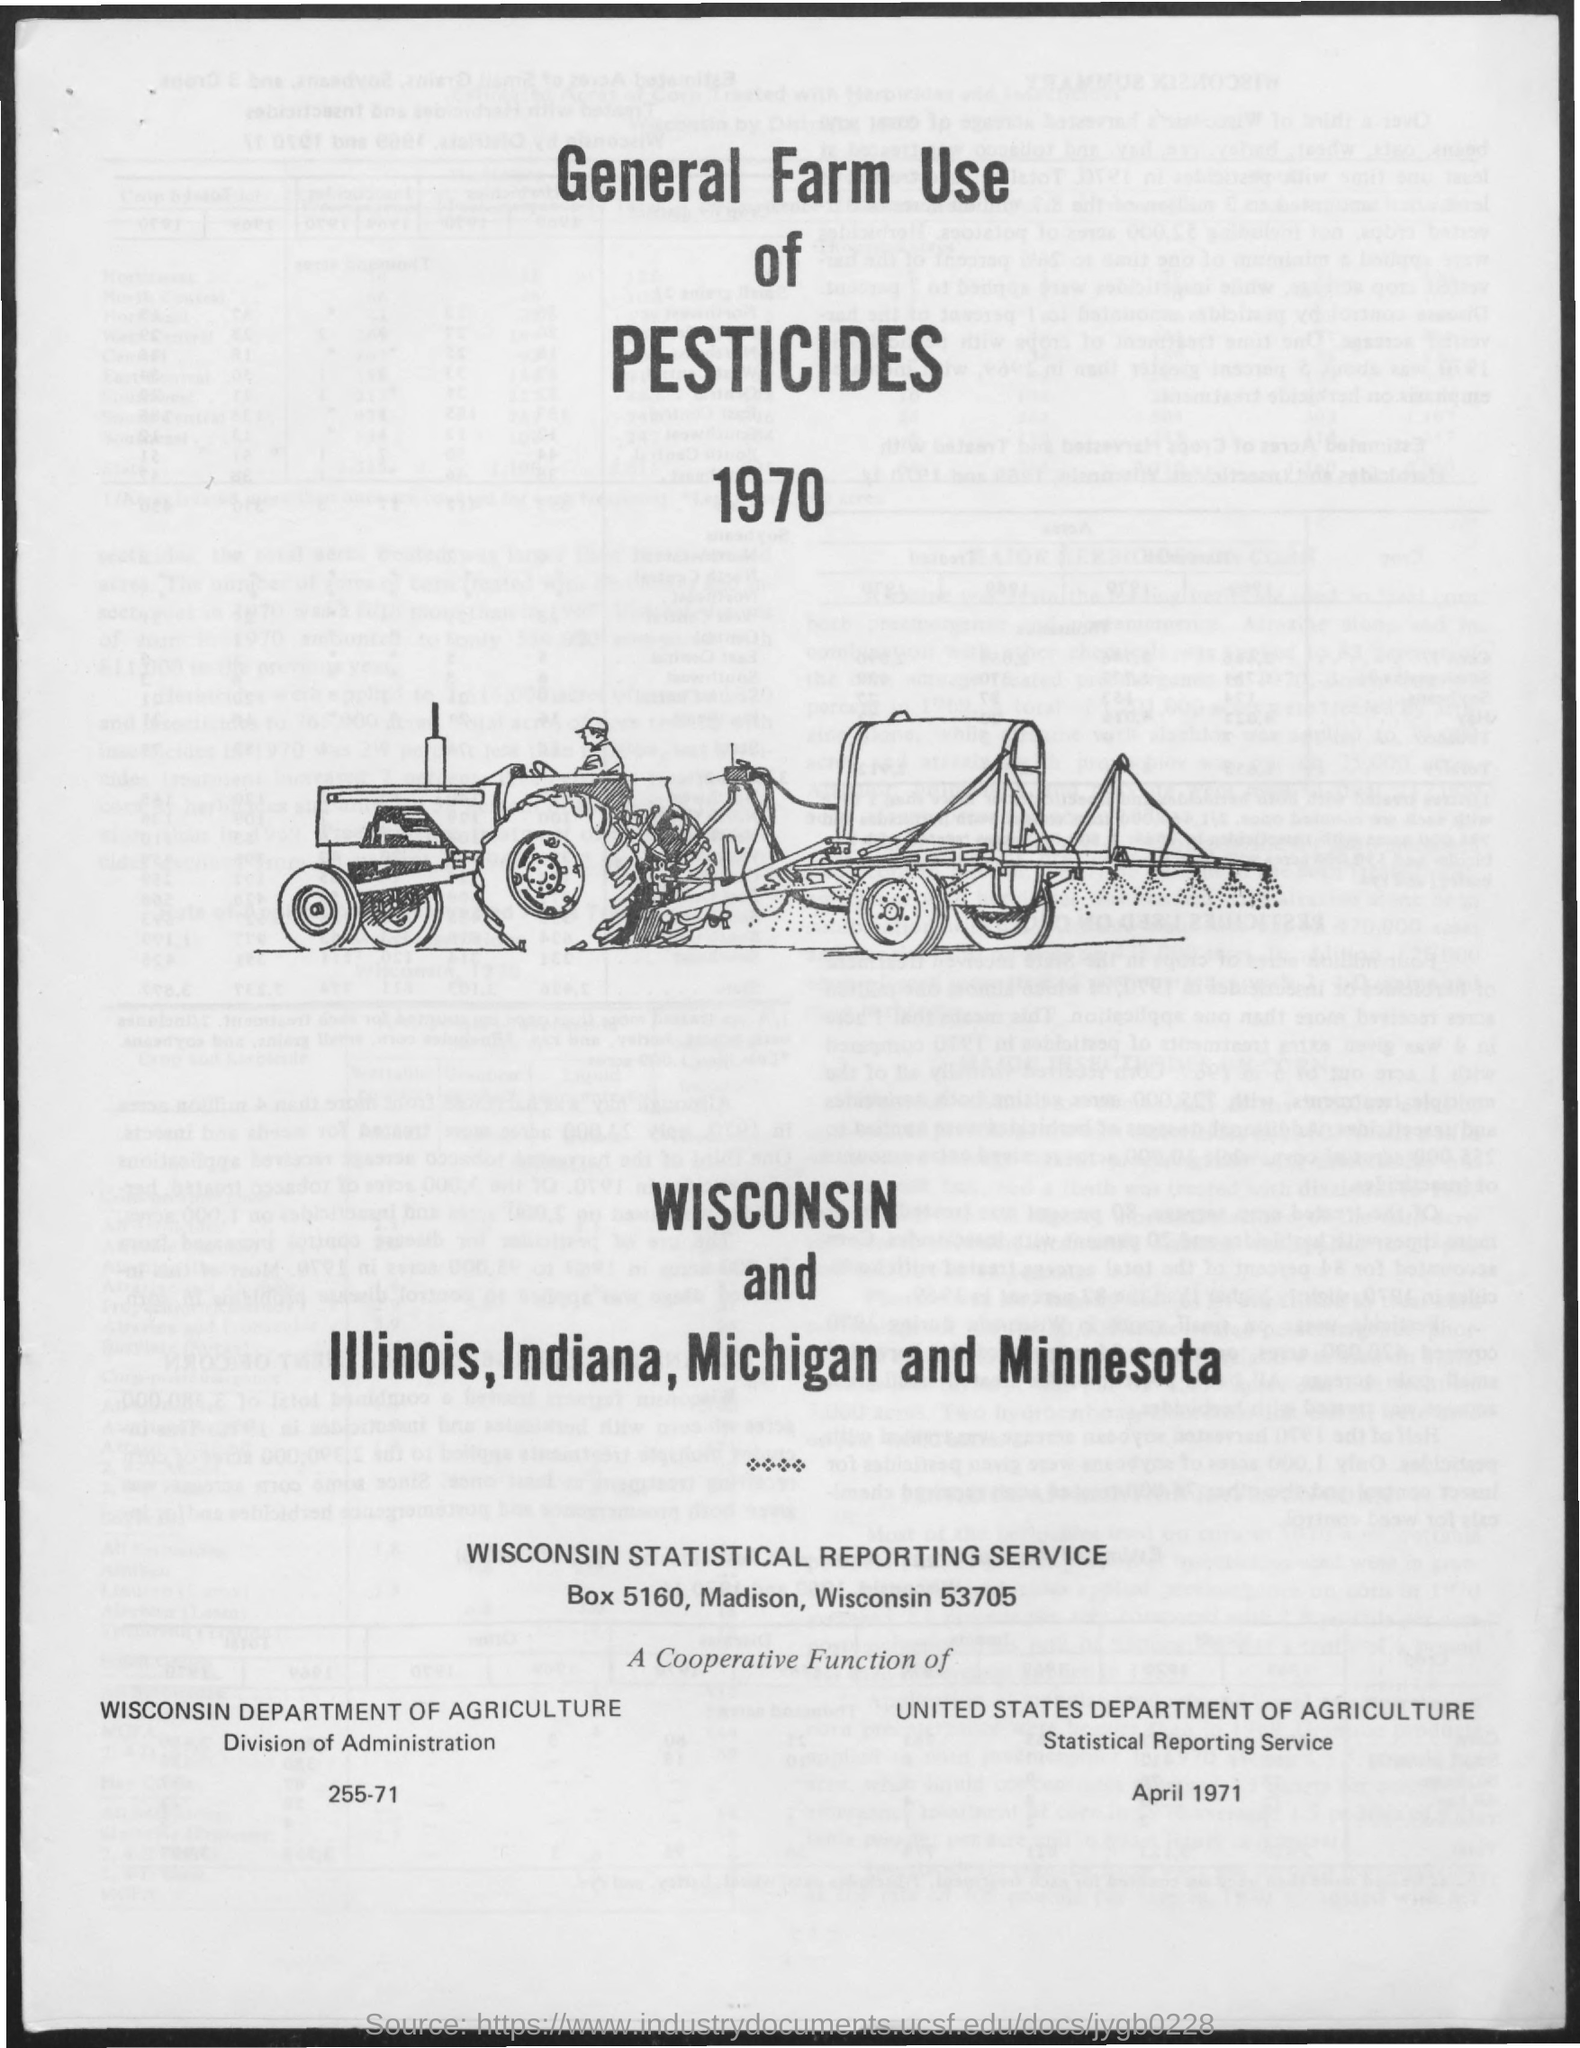What is the title of the document?
Offer a terse response. General Farm Use of Pesticides 1970. 